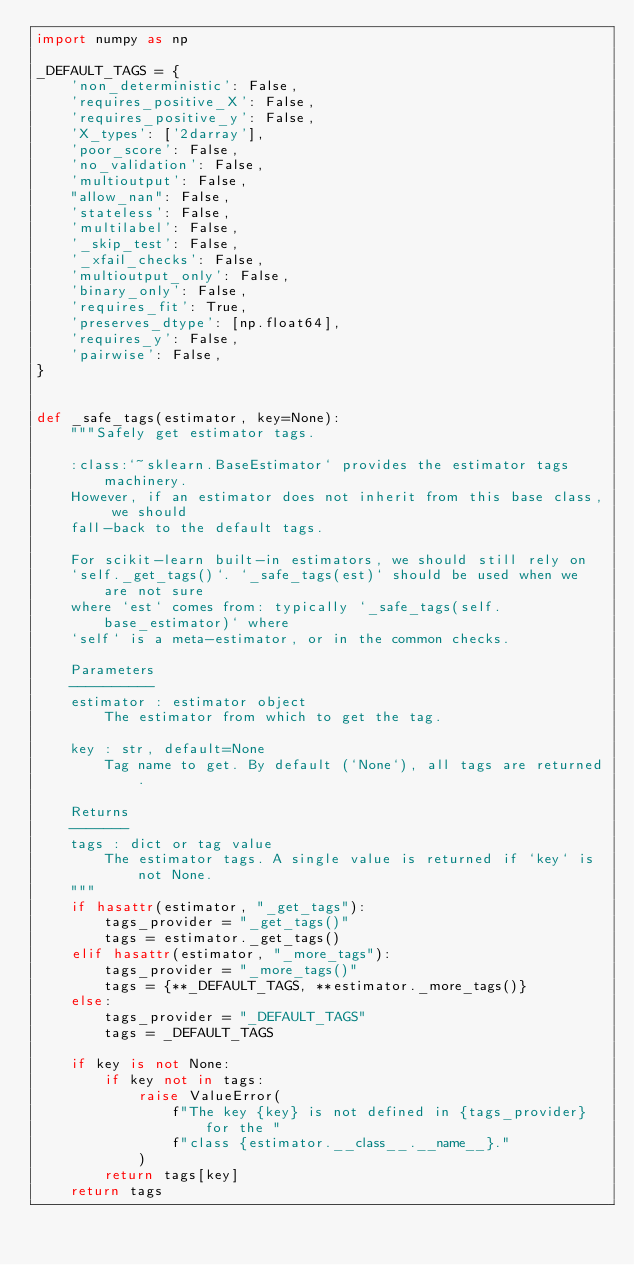Convert code to text. <code><loc_0><loc_0><loc_500><loc_500><_Python_>import numpy as np

_DEFAULT_TAGS = {
    'non_deterministic': False,
    'requires_positive_X': False,
    'requires_positive_y': False,
    'X_types': ['2darray'],
    'poor_score': False,
    'no_validation': False,
    'multioutput': False,
    "allow_nan": False,
    'stateless': False,
    'multilabel': False,
    '_skip_test': False,
    '_xfail_checks': False,
    'multioutput_only': False,
    'binary_only': False,
    'requires_fit': True,
    'preserves_dtype': [np.float64],
    'requires_y': False,
    'pairwise': False,
}


def _safe_tags(estimator, key=None):
    """Safely get estimator tags.

    :class:`~sklearn.BaseEstimator` provides the estimator tags machinery.
    However, if an estimator does not inherit from this base class, we should
    fall-back to the default tags.

    For scikit-learn built-in estimators, we should still rely on
    `self._get_tags()`. `_safe_tags(est)` should be used when we are not sure
    where `est` comes from: typically `_safe_tags(self.base_estimator)` where
    `self` is a meta-estimator, or in the common checks.

    Parameters
    ----------
    estimator : estimator object
        The estimator from which to get the tag.

    key : str, default=None
        Tag name to get. By default (`None`), all tags are returned.

    Returns
    -------
    tags : dict or tag value
        The estimator tags. A single value is returned if `key` is not None.
    """
    if hasattr(estimator, "_get_tags"):
        tags_provider = "_get_tags()"
        tags = estimator._get_tags()
    elif hasattr(estimator, "_more_tags"):
        tags_provider = "_more_tags()"
        tags = {**_DEFAULT_TAGS, **estimator._more_tags()}
    else:
        tags_provider = "_DEFAULT_TAGS"
        tags = _DEFAULT_TAGS

    if key is not None:
        if key not in tags:
            raise ValueError(
                f"The key {key} is not defined in {tags_provider} for the "
                f"class {estimator.__class__.__name__}."
            )
        return tags[key]
    return tags
</code> 